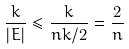Convert formula to latex. <formula><loc_0><loc_0><loc_500><loc_500>\frac { k } { | E | } \leq \frac { k } { n k / 2 } = \frac { 2 } { n }</formula> 